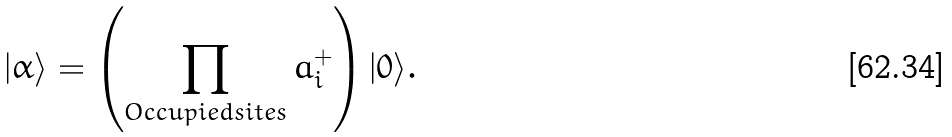Convert formula to latex. <formula><loc_0><loc_0><loc_500><loc_500>| \alpha \rangle = \left ( \prod _ { O c c u p i e d s i t e s } a ^ { + } _ { i } \right ) | 0 \rangle .</formula> 